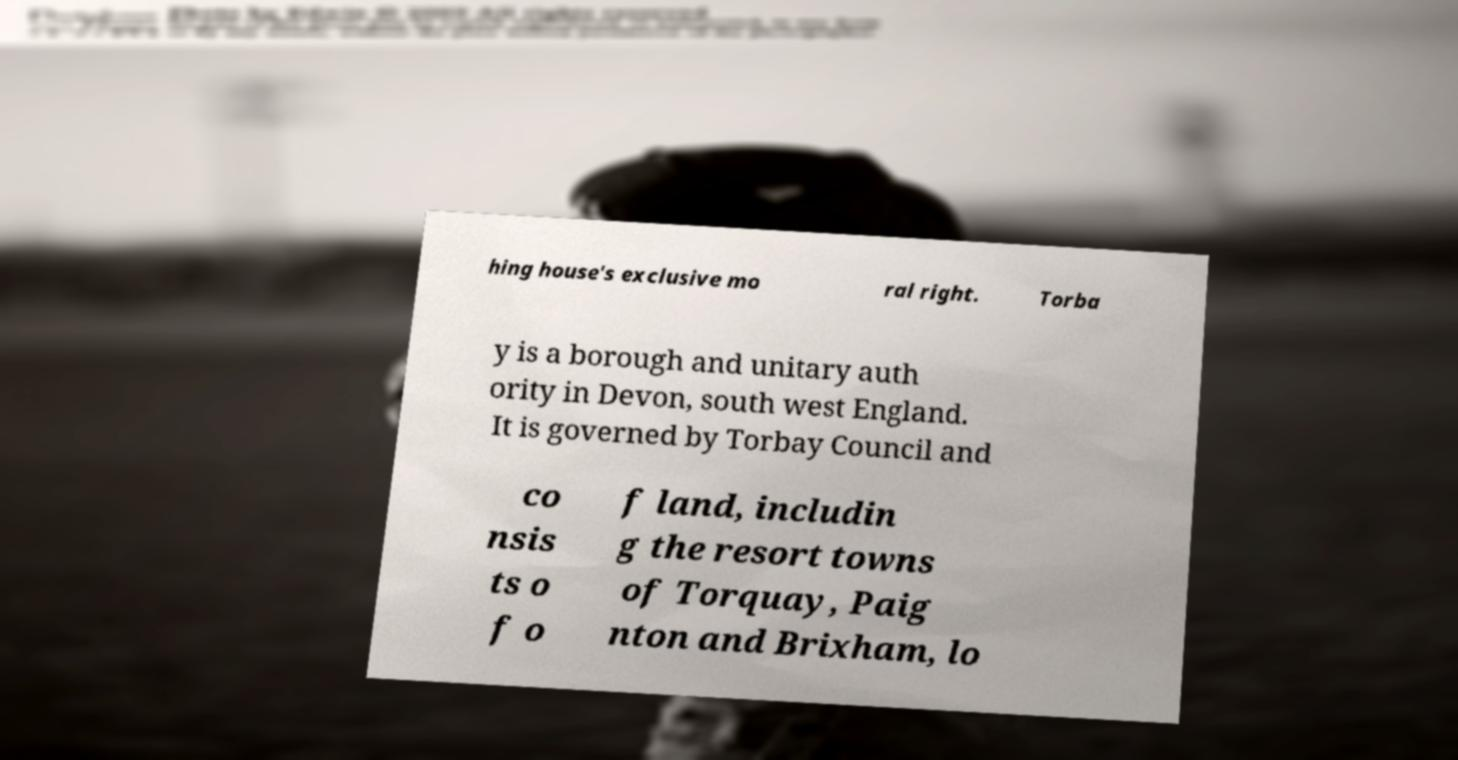For documentation purposes, I need the text within this image transcribed. Could you provide that? hing house's exclusive mo ral right. Torba y is a borough and unitary auth ority in Devon, south west England. It is governed by Torbay Council and co nsis ts o f o f land, includin g the resort towns of Torquay, Paig nton and Brixham, lo 